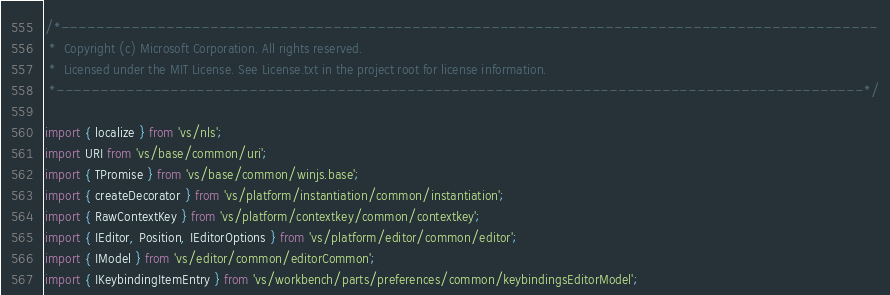<code> <loc_0><loc_0><loc_500><loc_500><_TypeScript_>/*---------------------------------------------------------------------------------------------
 *  Copyright (c) Microsoft Corporation. All rights reserved.
 *  Licensed under the MIT License. See License.txt in the project root for license information.
 *--------------------------------------------------------------------------------------------*/

import { localize } from 'vs/nls';
import URI from 'vs/base/common/uri';
import { TPromise } from 'vs/base/common/winjs.base';
import { createDecorator } from 'vs/platform/instantiation/common/instantiation';
import { RawContextKey } from 'vs/platform/contextkey/common/contextkey';
import { IEditor, Position, IEditorOptions } from 'vs/platform/editor/common/editor';
import { IModel } from 'vs/editor/common/editorCommon';
import { IKeybindingItemEntry } from 'vs/workbench/parts/preferences/common/keybindingsEditorModel';</code> 